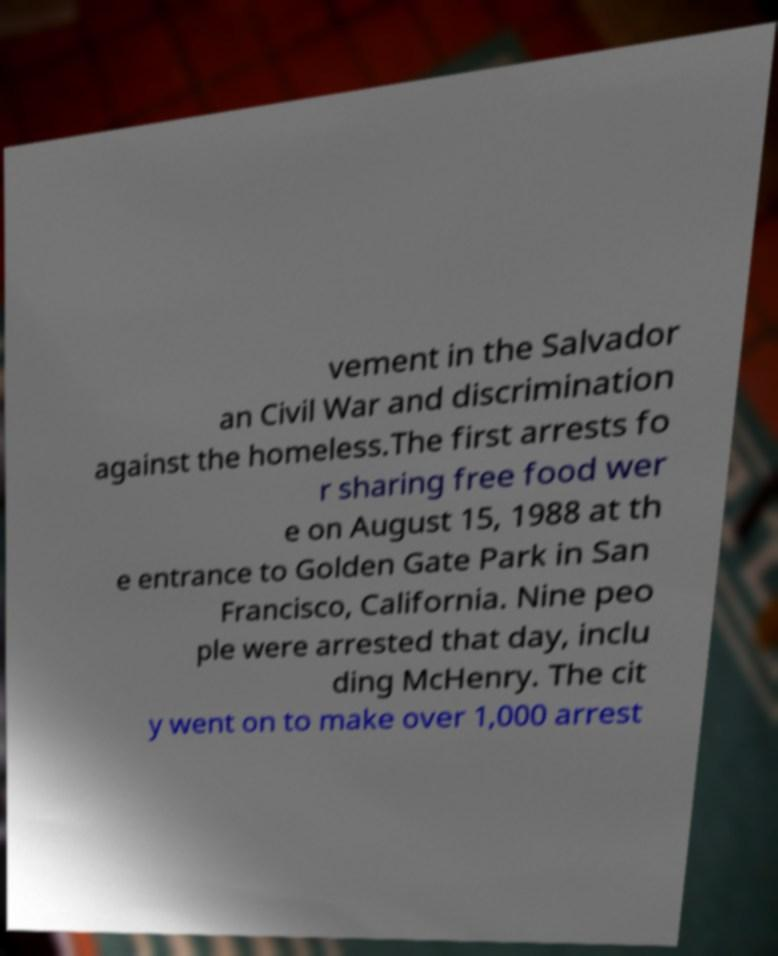Can you read and provide the text displayed in the image?This photo seems to have some interesting text. Can you extract and type it out for me? vement in the Salvador an Civil War and discrimination against the homeless.The first arrests fo r sharing free food wer e on August 15, 1988 at th e entrance to Golden Gate Park in San Francisco, California. Nine peo ple were arrested that day, inclu ding McHenry. The cit y went on to make over 1,000 arrest 